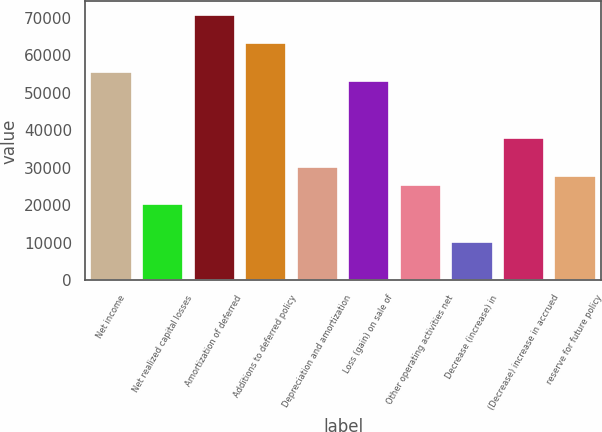Convert chart to OTSL. <chart><loc_0><loc_0><loc_500><loc_500><bar_chart><fcel>Net income<fcel>Net realized capital losses<fcel>Amortization of deferred<fcel>Additions to deferred policy<fcel>Depreciation and amortization<fcel>Loss (gain) on sale of<fcel>Other operating activities net<fcel>Decrease (increase) in<fcel>(Decrease) increase in accrued<fcel>reserve for future policy<nl><fcel>55667.8<fcel>20249.2<fcel>70847.2<fcel>63257.5<fcel>30368.8<fcel>53137.9<fcel>25309<fcel>10129.6<fcel>37958.5<fcel>27838.9<nl></chart> 